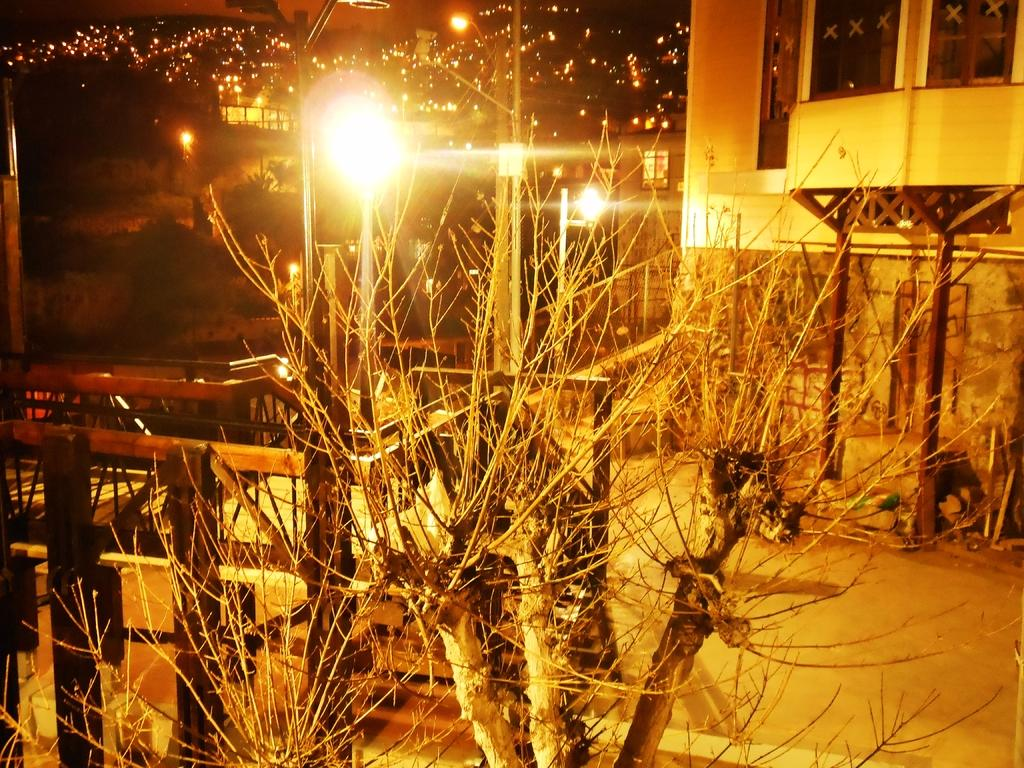What type of vegetation can be seen in the image? There are trees in the image. What type of structures are present in the image? There are buildings in the image. What color is the cheese in the image? There is no cheese present in the image. What type of insurance is being advertised on the buildings in the image? There is no advertisement or mention of insurance in the image. 